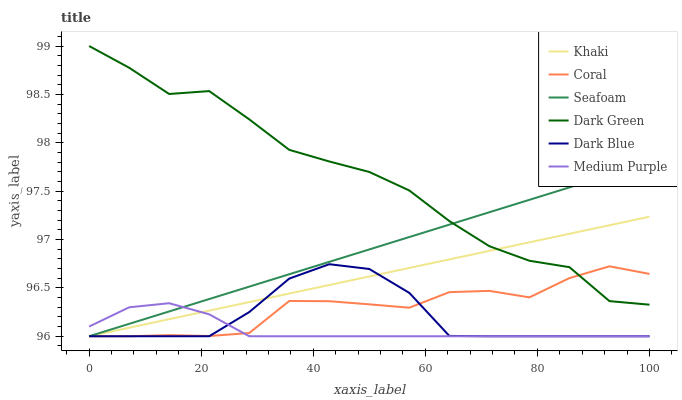Does Medium Purple have the minimum area under the curve?
Answer yes or no. Yes. Does Dark Green have the maximum area under the curve?
Answer yes or no. Yes. Does Coral have the minimum area under the curve?
Answer yes or no. No. Does Coral have the maximum area under the curve?
Answer yes or no. No. Is Khaki the smoothest?
Answer yes or no. Yes. Is Dark Green the roughest?
Answer yes or no. Yes. Is Coral the smoothest?
Answer yes or no. No. Is Coral the roughest?
Answer yes or no. No. Does Khaki have the lowest value?
Answer yes or no. Yes. Does Dark Green have the lowest value?
Answer yes or no. No. Does Dark Green have the highest value?
Answer yes or no. Yes. Does Coral have the highest value?
Answer yes or no. No. Is Medium Purple less than Dark Green?
Answer yes or no. Yes. Is Dark Green greater than Medium Purple?
Answer yes or no. Yes. Does Khaki intersect Dark Green?
Answer yes or no. Yes. Is Khaki less than Dark Green?
Answer yes or no. No. Is Khaki greater than Dark Green?
Answer yes or no. No. Does Medium Purple intersect Dark Green?
Answer yes or no. No. 